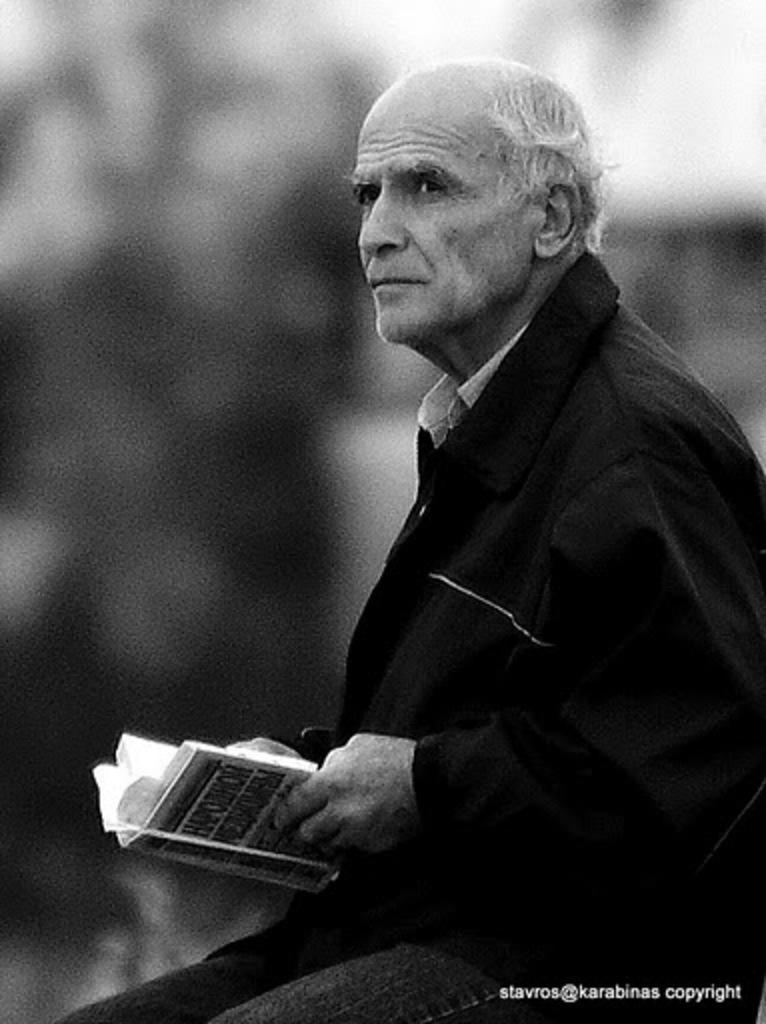What is the main subject of the image? There is a person in the image. What is the person holding in the image? The person is holding a book. Can you describe the background of the image? The background of the image is dark. What type of sponge can be seen in the image? There is no sponge present in the image. What is the person using the twig for in the image? There is no twig present in the image. 